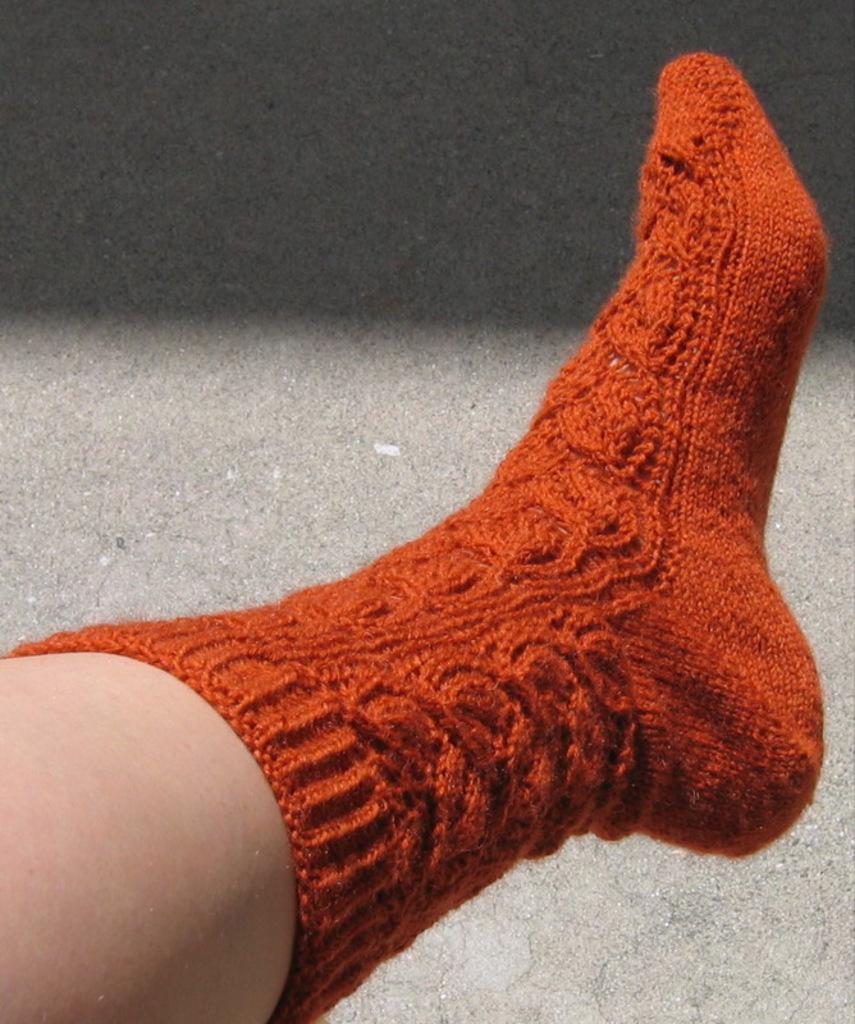Describe this image in one or two sentences. Here we can see a person wore a sock to his leg and this is floor. 